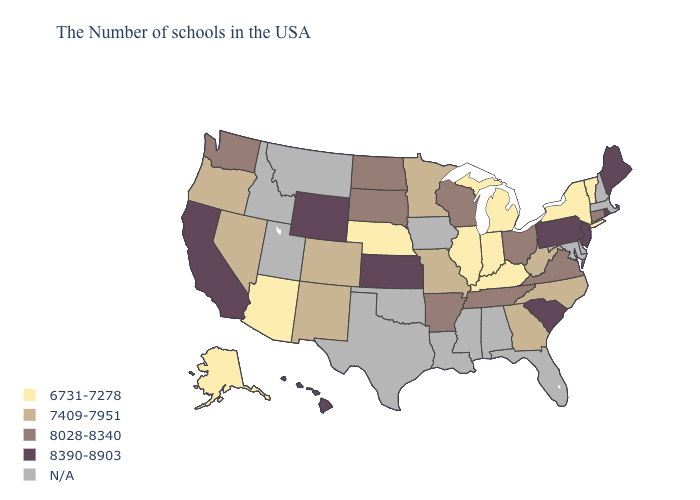Does the first symbol in the legend represent the smallest category?
Be succinct. Yes. Does Vermont have the lowest value in the Northeast?
Keep it brief. Yes. Does Hawaii have the lowest value in the USA?
Answer briefly. No. What is the value of Georgia?
Answer briefly. 7409-7951. Does Alaska have the highest value in the West?
Answer briefly. No. Name the states that have a value in the range 6731-7278?
Short answer required. Vermont, New York, Michigan, Kentucky, Indiana, Illinois, Nebraska, Arizona, Alaska. Among the states that border North Dakota , which have the highest value?
Write a very short answer. South Dakota. Does Maine have the highest value in the USA?
Write a very short answer. Yes. Name the states that have a value in the range 8028-8340?
Write a very short answer. Connecticut, Virginia, Ohio, Tennessee, Wisconsin, Arkansas, South Dakota, North Dakota, Washington. What is the highest value in the USA?
Keep it brief. 8390-8903. Name the states that have a value in the range 8390-8903?
Quick response, please. Maine, Rhode Island, New Jersey, Pennsylvania, South Carolina, Kansas, Wyoming, California, Hawaii. Does South Carolina have the highest value in the South?
Be succinct. Yes. Name the states that have a value in the range N/A?
Short answer required. Massachusetts, New Hampshire, Delaware, Maryland, Florida, Alabama, Mississippi, Louisiana, Iowa, Oklahoma, Texas, Utah, Montana, Idaho. Name the states that have a value in the range 8028-8340?
Concise answer only. Connecticut, Virginia, Ohio, Tennessee, Wisconsin, Arkansas, South Dakota, North Dakota, Washington. 